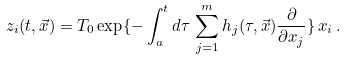<formula> <loc_0><loc_0><loc_500><loc_500>z _ { i } ( t , \vec { x } ) = { T } _ { 0 } \exp \{ - \int _ { a } ^ { t } d \tau \, \sum _ { j = 1 } ^ { m } h _ { j } ( \tau , \vec { x } ) \frac { \partial } { \partial x _ { j } } \} \, x _ { i } \, .</formula> 